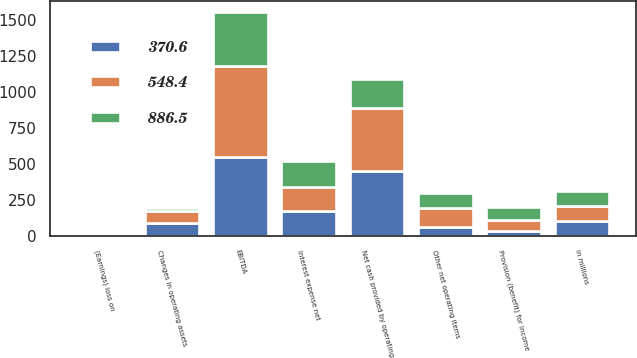Convert chart. <chart><loc_0><loc_0><loc_500><loc_500><stacked_bar_chart><ecel><fcel>in millions<fcel>Net cash provided by operating<fcel>Changes in operating assets<fcel>Other net operating items<fcel>(Earnings) loss on<fcel>Provision (benefit) for income<fcel>Interest expense net<fcel>EBITDA<nl><fcel>886.5<fcel>102.9<fcel>202.7<fcel>20<fcel>102.9<fcel>6<fcel>89.7<fcel>180.7<fcel>370.6<nl><fcel>370.6<fcel>102.9<fcel>453<fcel>90.3<fcel>62.2<fcel>11.7<fcel>37.8<fcel>173<fcel>548.4<nl><fcel>548.4<fcel>102.9<fcel>435.2<fcel>85.2<fcel>130.4<fcel>2.4<fcel>71.7<fcel>169.7<fcel>633.8<nl></chart> 